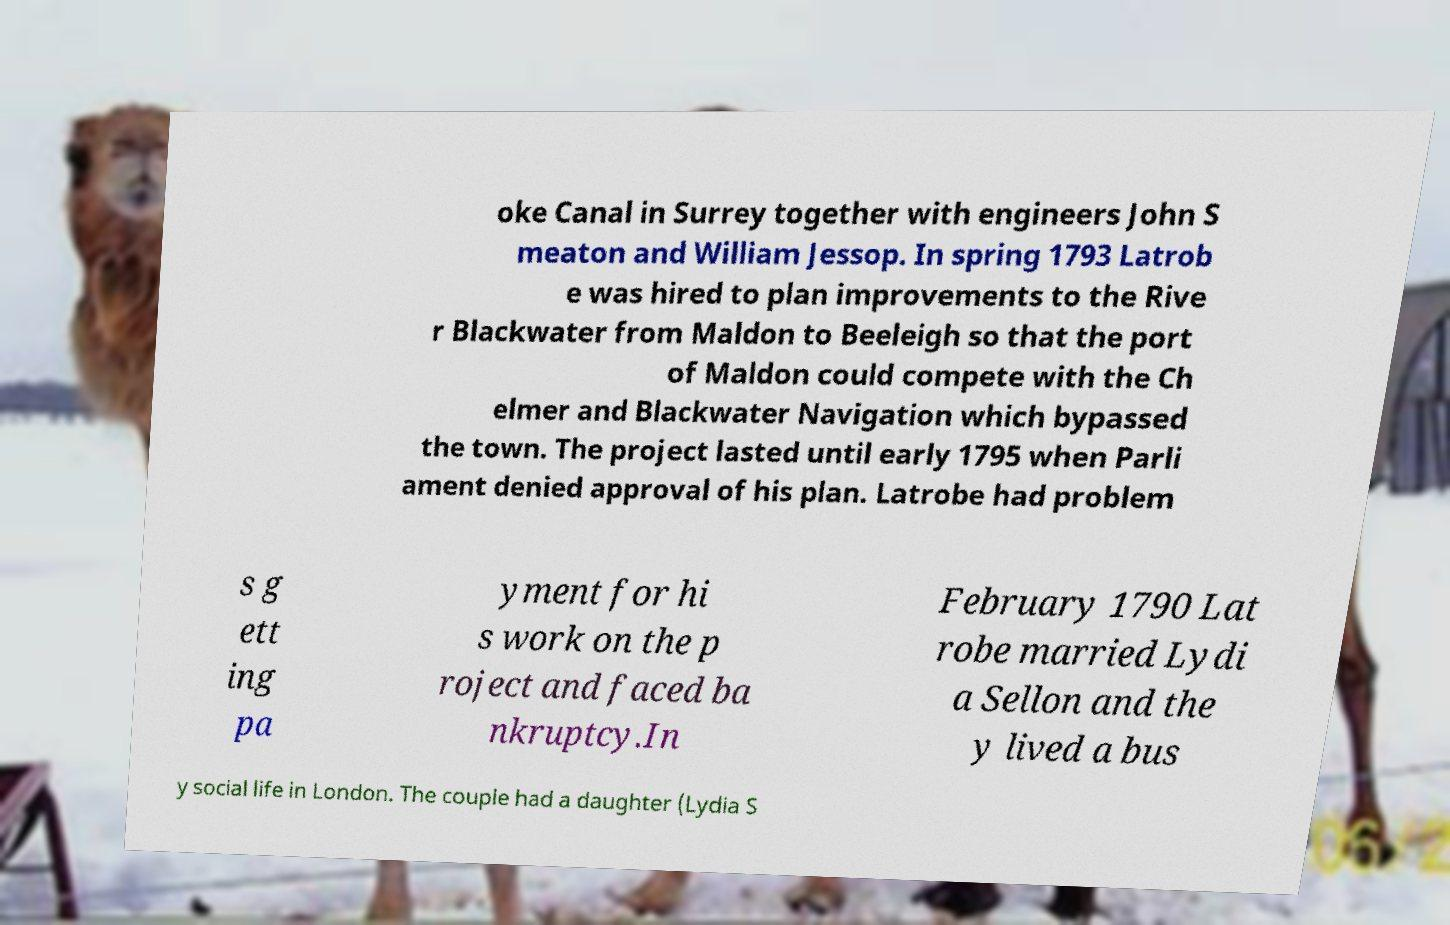Please read and relay the text visible in this image. What does it say? oke Canal in Surrey together with engineers John S meaton and William Jessop. In spring 1793 Latrob e was hired to plan improvements to the Rive r Blackwater from Maldon to Beeleigh so that the port of Maldon could compete with the Ch elmer and Blackwater Navigation which bypassed the town. The project lasted until early 1795 when Parli ament denied approval of his plan. Latrobe had problem s g ett ing pa yment for hi s work on the p roject and faced ba nkruptcy.In February 1790 Lat robe married Lydi a Sellon and the y lived a bus y social life in London. The couple had a daughter (Lydia S 